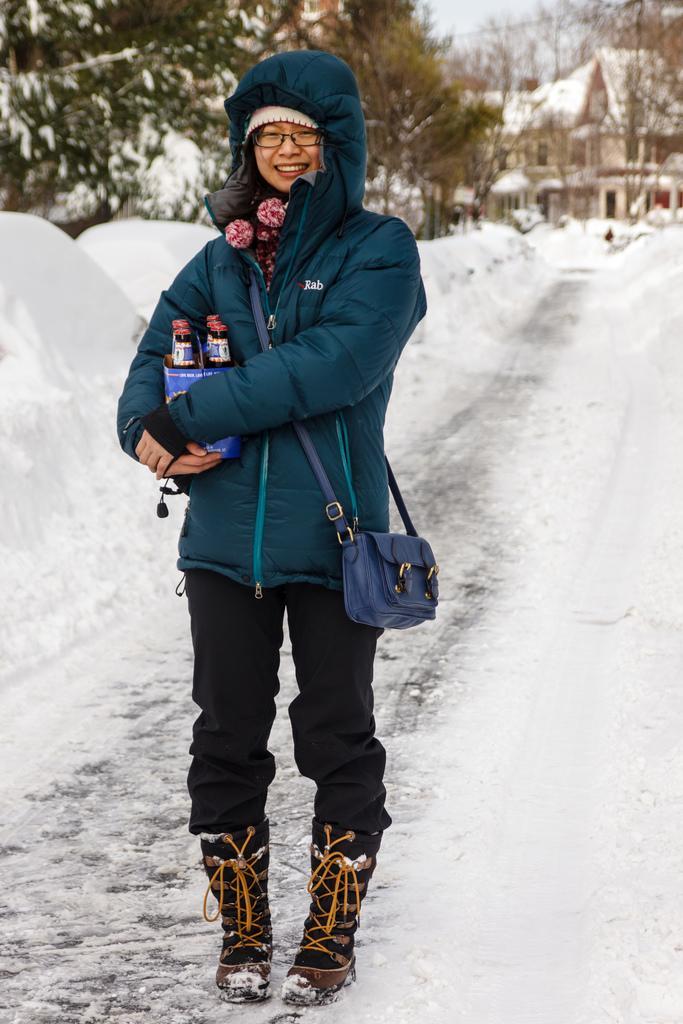How would you summarize this image in a sentence or two? The picture is clicked outside a city on a street. In the foreground of the picture there is a woman standing holding a case of beers. To the right there is snow. On the left there is also snow. In the top left there are trees. On the top right there are houses. 